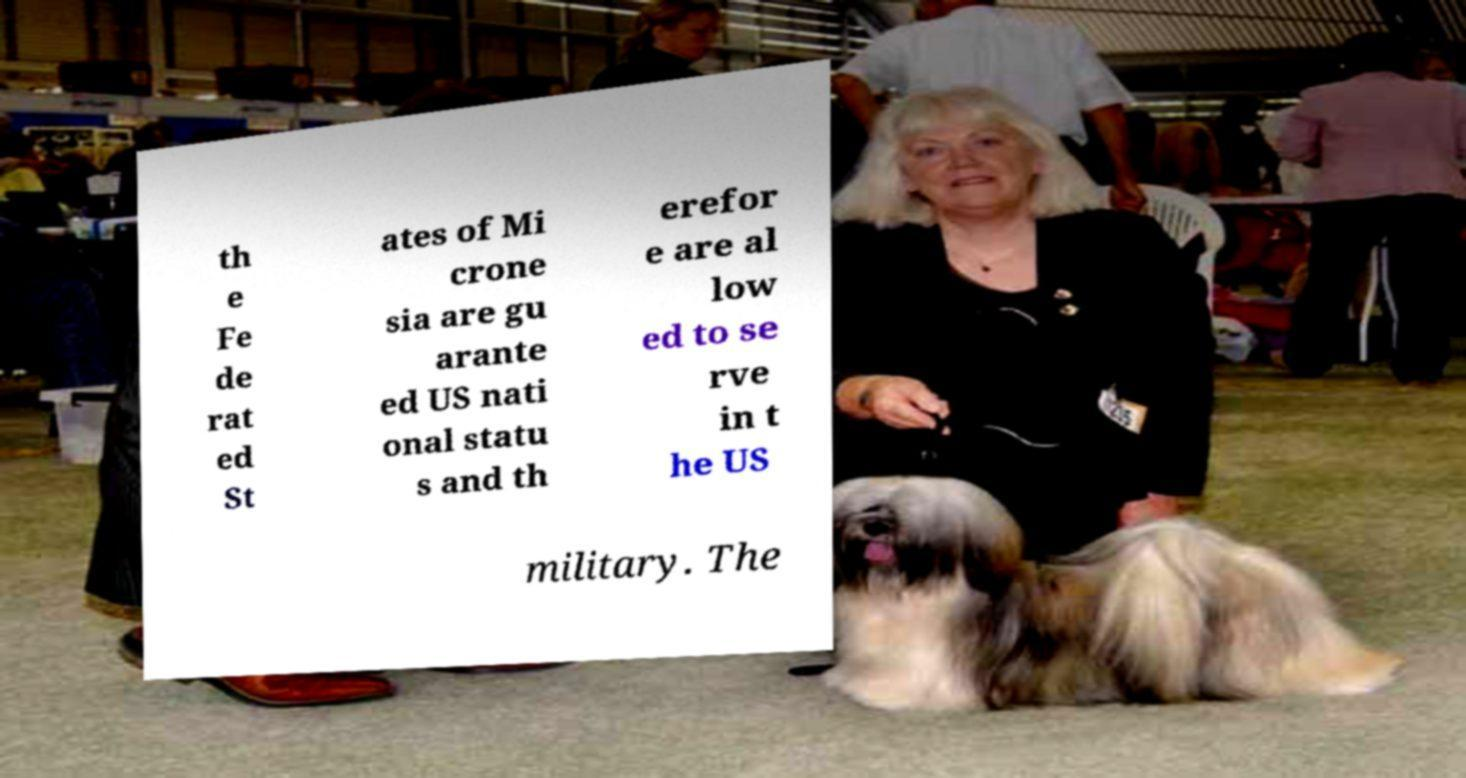For documentation purposes, I need the text within this image transcribed. Could you provide that? th e Fe de rat ed St ates of Mi crone sia are gu arante ed US nati onal statu s and th erefor e are al low ed to se rve in t he US military. The 